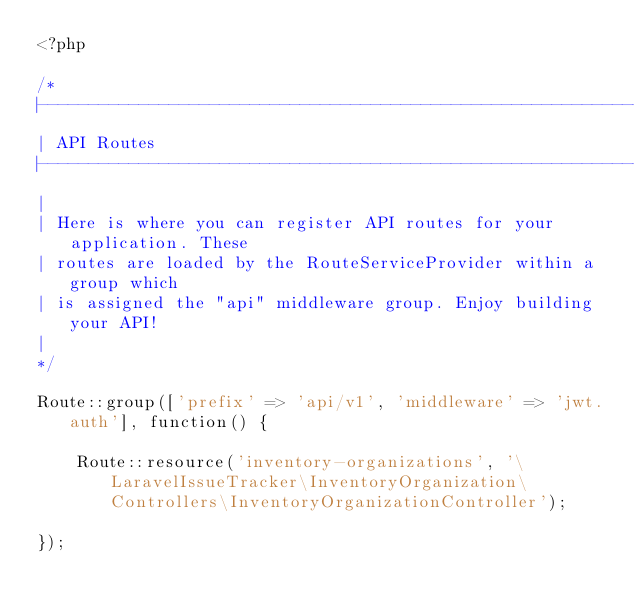<code> <loc_0><loc_0><loc_500><loc_500><_PHP_><?php

/*
|--------------------------------------------------------------------------
| API Routes
|--------------------------------------------------------------------------
|
| Here is where you can register API routes for your application. These
| routes are loaded by the RouteServiceProvider within a group which
| is assigned the "api" middleware group. Enjoy building your API!
|
*/

Route::group(['prefix' => 'api/v1', 'middleware' => 'jwt.auth'], function() {

    Route::resource('inventory-organizations', '\LaravelIssueTracker\InventoryOrganization\Controllers\InventoryOrganizationController');

});</code> 